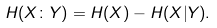<formula> <loc_0><loc_0><loc_500><loc_500>H ( X \colon Y ) = H ( X ) - H ( X | Y ) .</formula> 